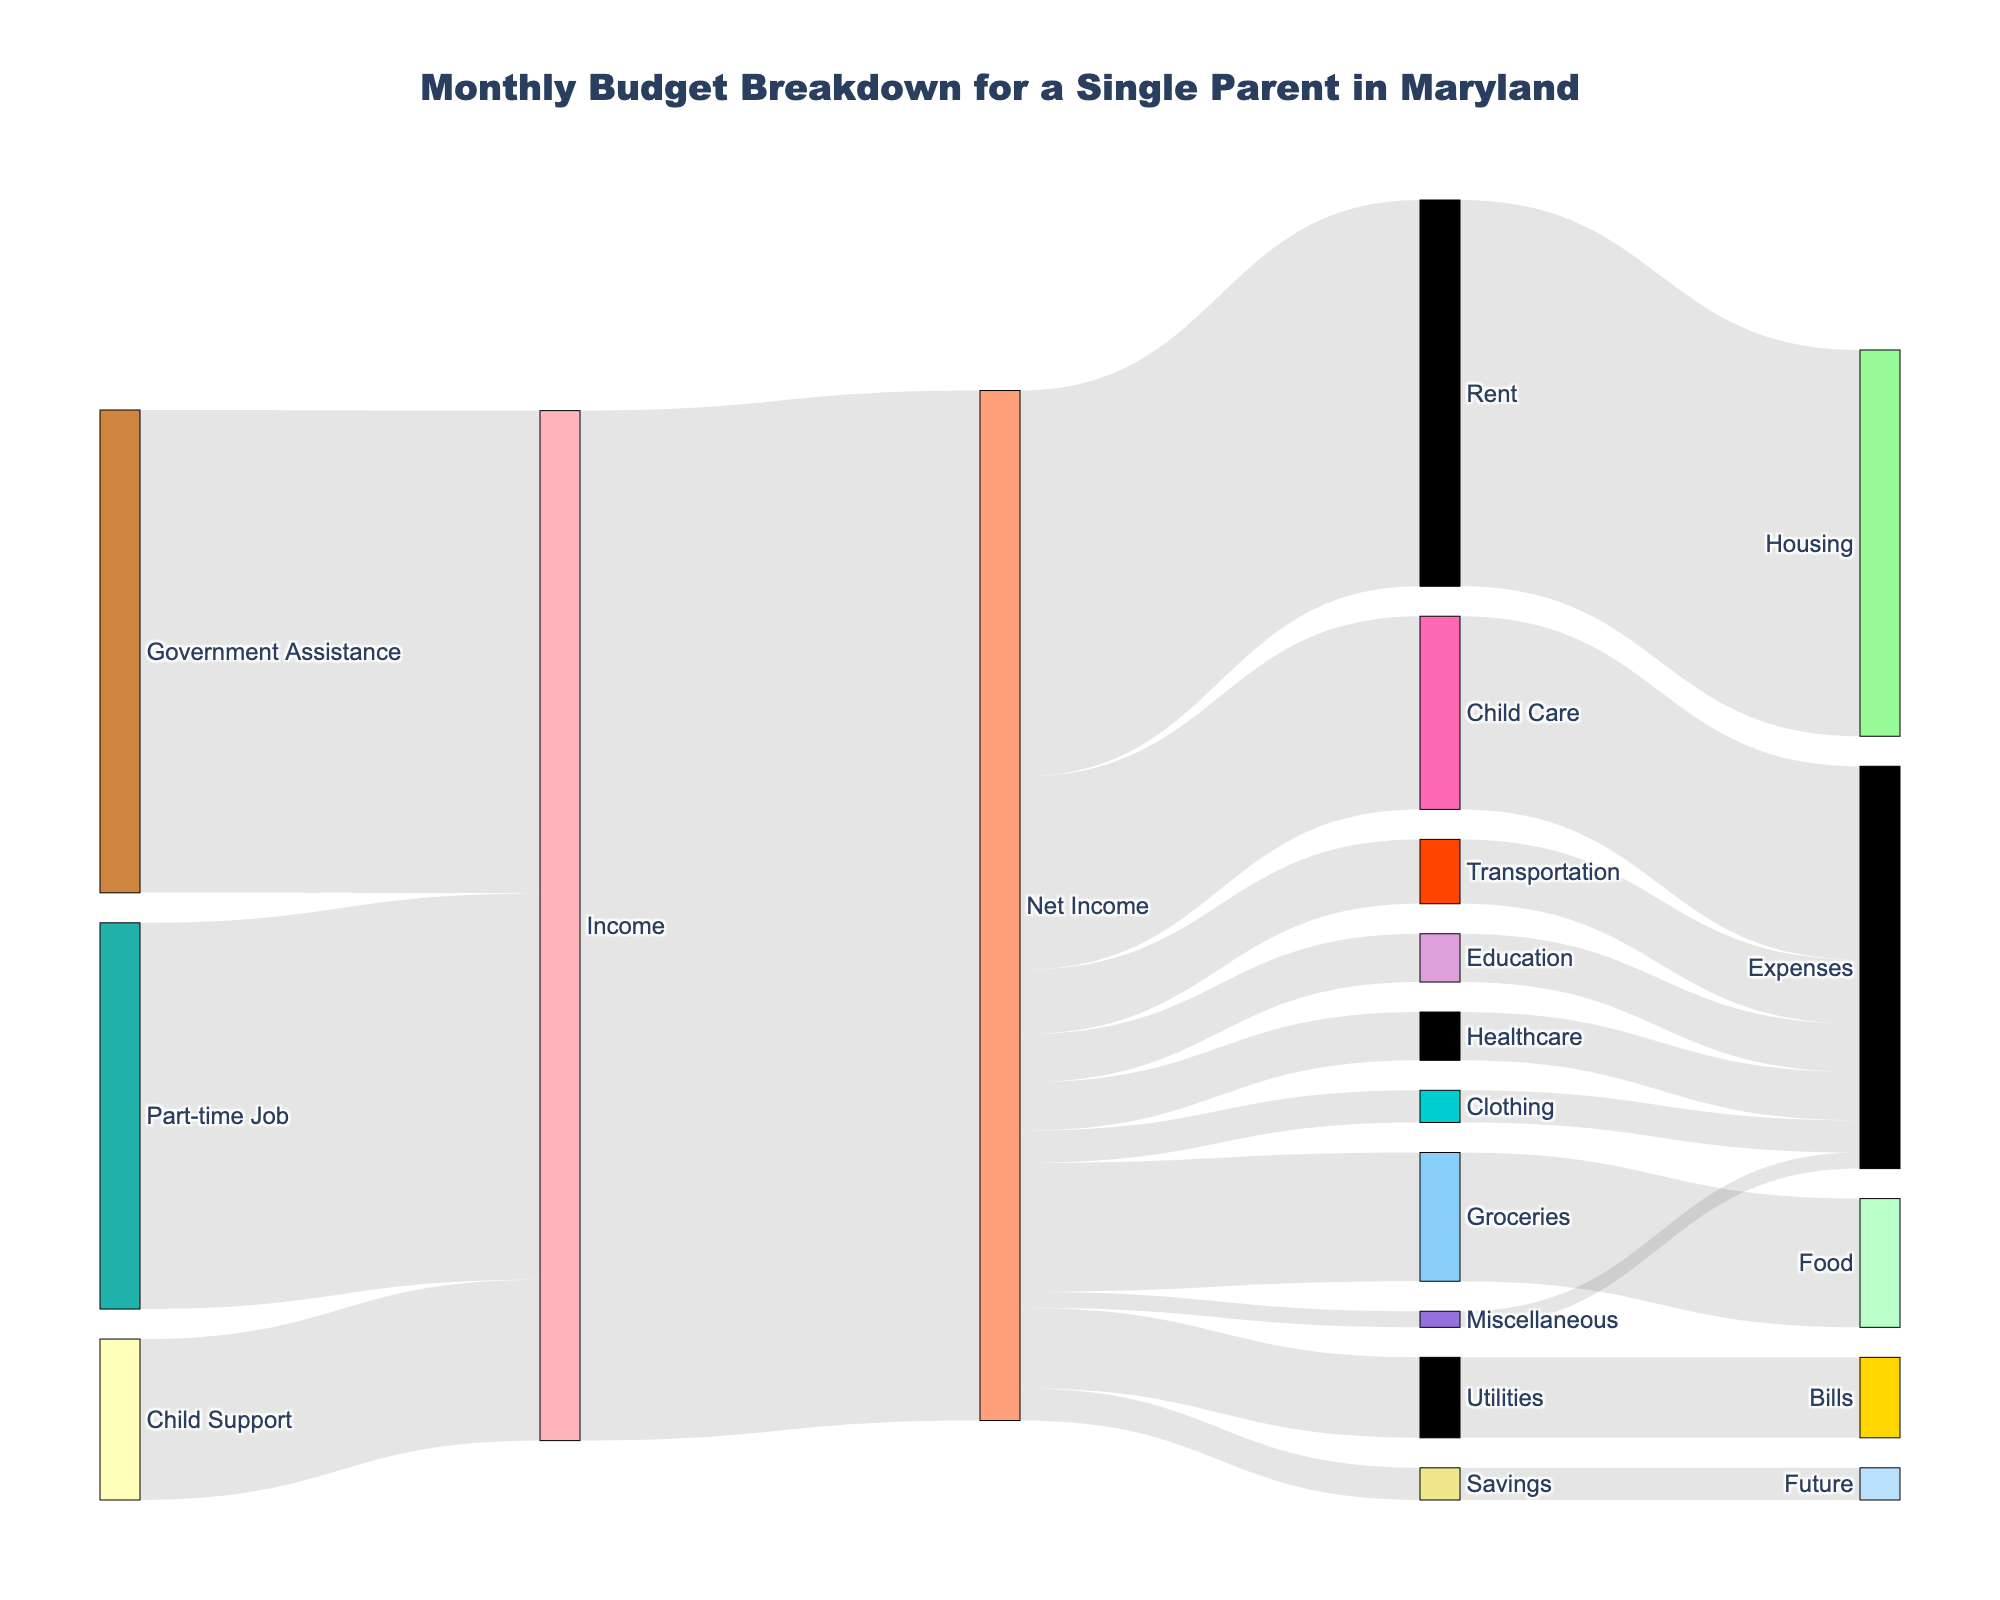what is the total income for the single parent household? The total income can be calculated by summing the values from the sources "Child Support" ($500), "Part-time Job" ($1200), and "Government Assistance" ($1500). So, the total income is 500 + 1200 + 1500 = $3200.
Answer: $3200 What is the largest expense category? By looking at the values linked to "Net Income," we see that the "Rent" category has the highest value of $1200.
Answer: Rent How much money is allocated to transportation? From the Net Income node, there is a flow to "Transportation" with a value of $200.
Answer: $200 What percentage of the net income is spent on child care? The net income is $3200, and the amount spent on child care is $600. The percentage is calculated as (600 / 3200) * 100 = 18.75%.
Answer: 18.75% What is the total amount spent on healthcare and education combined? Healthcare expenses are $150 and education expenses are $150. Adding these together gives 150 + 150 = $300.
Answer: $300 Compare the amount spent on groceries and utilities: which one is higher and by how much? Groceries account for $400 and utilities for $250. The difference is 400 - 250 = $150, so groceries are higher by $150.
Answer: Groceries are higher by $150 How much money is left for miscellaneous expenses? From the Net Income node, the flow to "Miscellaneous" has a value of $50.
Answer: $50 Which category receives the least funding, and how much is it? According to the diagram, the "Savings" and "Miscellaneous" categories both receive the least amount, which is $50.
Answer: Savings and Miscellaneous, $50 each 